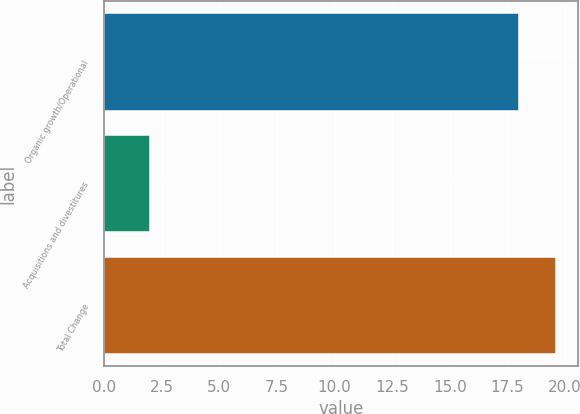<chart> <loc_0><loc_0><loc_500><loc_500><bar_chart><fcel>Organic growth/Operational<fcel>Acquisitions and divestitures<fcel>Total Change<nl><fcel>18<fcel>2<fcel>19.6<nl></chart> 